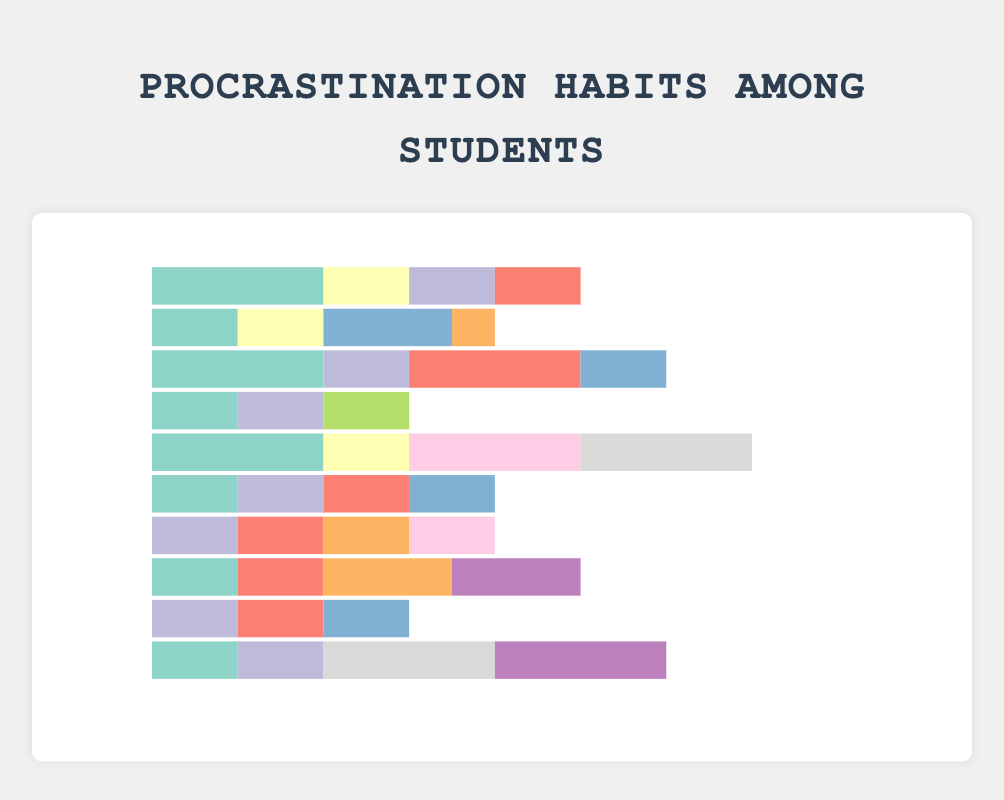1. Which student spends the most time studying? By looking at the lengths of the study hours bars, Fay has the longest bar among the students.
Answer: Fay 2. Who spends more time on social media, Alice or Charlie? Alice spends 2 hours and Charlie spends 2 hours on social media. By comparing these, we see they both spend an equal amount of time.
Answer: They spend the same amount of time 3. What is the total time Ethan spends on distractions? Ethan's distractions are Watching TV (2 hours), Video Games (1 hour), Social Media (2 hours), and Listening to Music (2 hours). Summing these up: 2 + 1 + 2 + 2 = 7 hours.
Answer: 7 hours 4. How much more time does Jack spend on playing sports compared to Henry? Jack spends 2 hours and Henry spends 1.5 hours on playing sports. The difference is 2 - 1.5 = 0.5 hours.
Answer: 0.5 hours 5. Which activity is the most distracting for Bob? By comparing the bars for Bob's distraction activities, Netflix has the longest bar (1.5 hours).
Answer: Netflix 6. Who spends the least time studying and how much time do they spend on Netflix? Ivy spends the least amount of time studying (3 hours). Ivy spends 1 hour on Netflix.
Answer: Ivy spends 1 hour on Netflix 7. What is the sum of study hours for Alice, Charlie, and Fay combined? Alice studies 5 hours, Charlie studies 6 hours, and Fay studies 8 hours. Summing these: 5 + 6 + 8 = 19 hours.
Answer: 19 hours 8. Which student has the most diverse set of distractions (i.e., most different types)? By counting the number of different activities for each student, Ethan and Jack both have 4 different types.
Answer: Ethan and Jack 9. What is the average time spent on YouTube across all students? Total YouTube time = Alice (1) + Charlie (1) + Daphne (1) + Fay (1) + Grace (1) + Ivy (1) + Jack (1) = 7 hours. Number of students = 10. Average = 7 / 10 = 0.7 hours.
Answer: 0.7 hours 10. How much more time does Ethan spend on social media compared to Henry? Ethan spends 2 hours and Henry spends 1 hour on social media. The difference is 2 - 1 = 1 hour.
Answer: 1 hour 